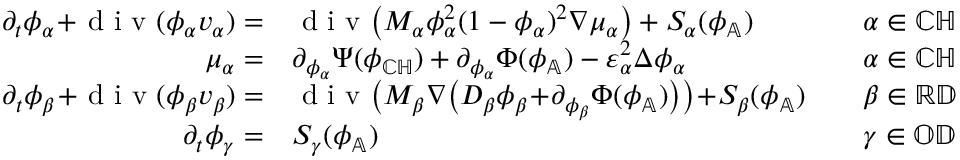Convert formula to latex. <formula><loc_0><loc_0><loc_500><loc_500>\begin{array} { r l r l } { \partial _ { t } \phi _ { \alpha } \, + \, d i v ( \phi _ { \alpha } v _ { \alpha } ) = } & { d i v \left ( M _ { \alpha } \phi _ { \alpha } ^ { 2 } ( 1 - \phi _ { \alpha } ) ^ { 2 } \nabla \mu _ { \alpha } \right ) + S _ { \alpha } ( \phi _ { \mathbb { A } } ) } & & { \alpha \in { \mathbb { C } \mathbb { H } } } \\ { \mu _ { \alpha } = } & { \partial _ { \phi _ { \alpha } } \Psi ( \phi _ { \mathbb { C } \mathbb { H } } ) + \partial _ { \phi _ { \alpha } } \Phi ( \phi _ { \mathbb { A } } ) - \varepsilon _ { \alpha } ^ { 2 } \Delta \phi _ { \alpha } } & & { \alpha \in { \mathbb { C } \mathbb { H } } } \\ { \partial _ { t } \phi _ { \beta } \, + \, d i v ( \phi _ { \beta } v _ { \beta } ) = } & { d i v \left ( M _ { \beta } \nabla \left ( D _ { \beta } \phi _ { \beta } \, + \, \partial _ { \phi _ { \beta } } \Phi ( \phi _ { \mathbb { A } } ) \right ) \right ) \, + \, S _ { \beta } ( \phi _ { \mathbb { A } } ) } & & { \beta \in { \mathbb { R } \mathbb { D } } } \\ { \partial _ { t } \phi _ { \gamma } = } & { S _ { \gamma } ( \phi _ { \mathbb { A } } ) } & & { \gamma \in { \mathbb { O } \mathbb { D } } } \end{array}</formula> 